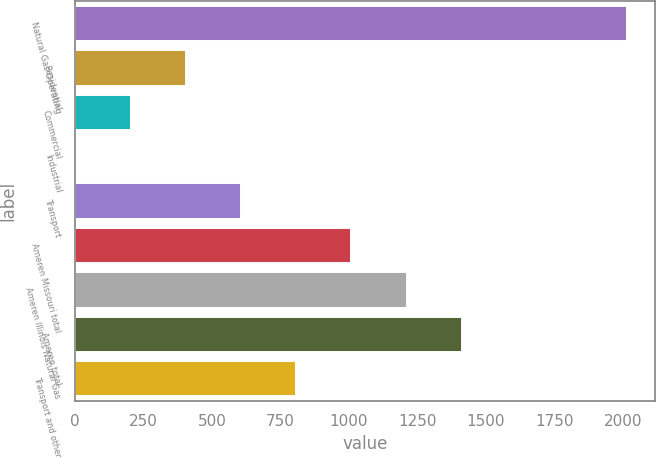Convert chart. <chart><loc_0><loc_0><loc_500><loc_500><bar_chart><fcel>Natural Gas Operating<fcel>Residential<fcel>Commercial<fcel>Industrial<fcel>Transport<fcel>Ameren Missouri total<fcel>Ameren Illinois Natural Gas<fcel>Ameren total<fcel>Transport and other<nl><fcel>2016<fcel>404<fcel>202.5<fcel>1<fcel>605.5<fcel>1008.5<fcel>1210<fcel>1411.5<fcel>807<nl></chart> 